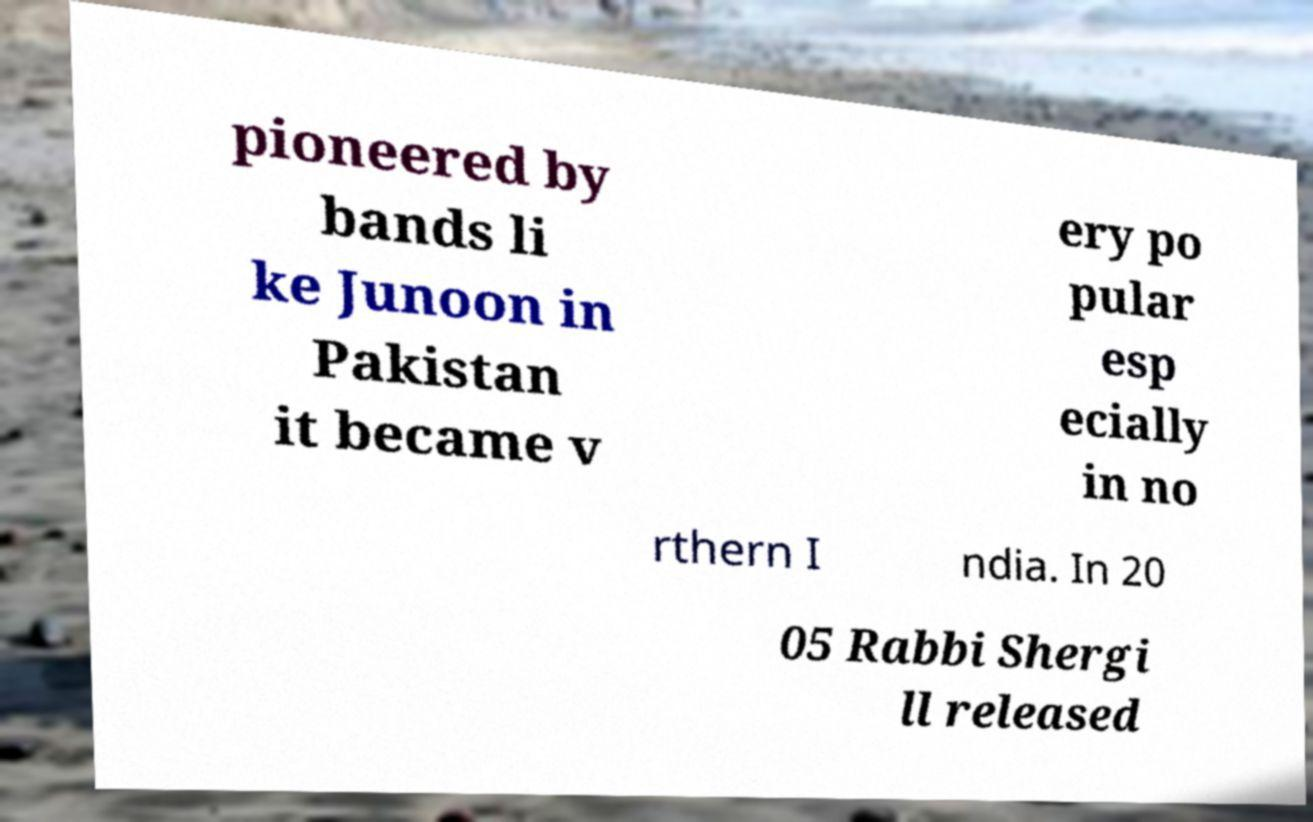Can you accurately transcribe the text from the provided image for me? pioneered by bands li ke Junoon in Pakistan it became v ery po pular esp ecially in no rthern I ndia. In 20 05 Rabbi Shergi ll released 